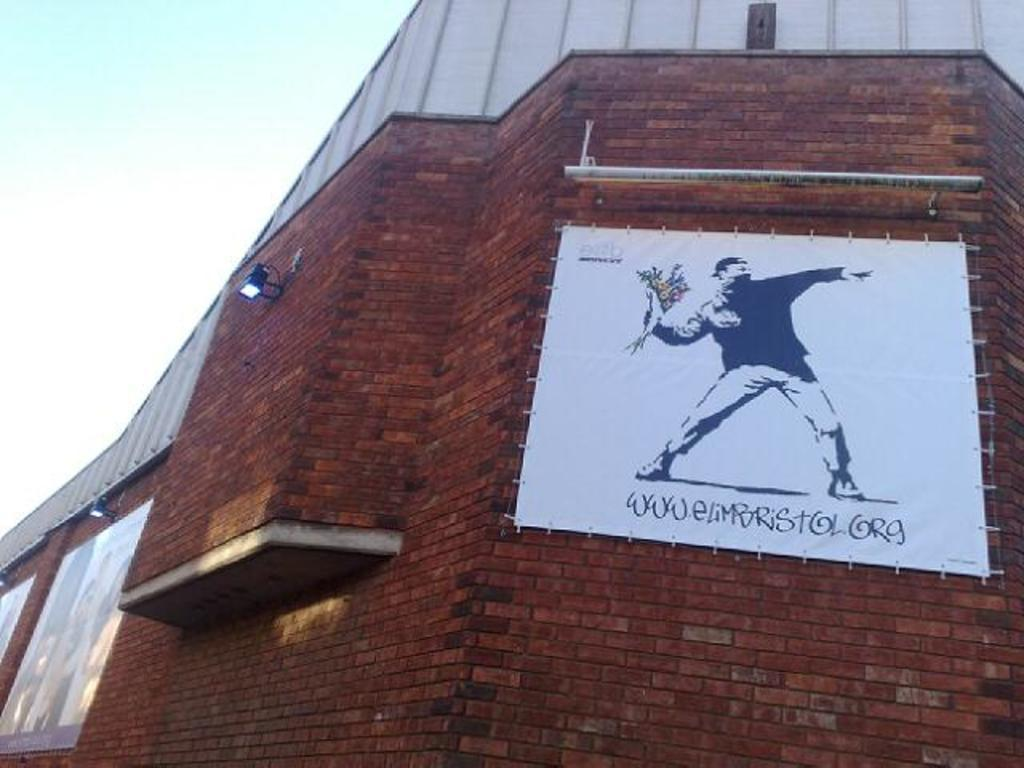What is the main structure in the image? There is a building in the image. What can be seen on the building? There are lights on the building and a poster on it. What is depicted on the poster? The poster contains a picture. What else is present on the poster besides the picture? There is text written on the poster. How many cacti are visible in the image? There are no cacti present in the image. What type of step is shown on the building in the image? There is no step depicted on the building in the image. 